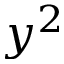<formula> <loc_0><loc_0><loc_500><loc_500>y ^ { 2 }</formula> 